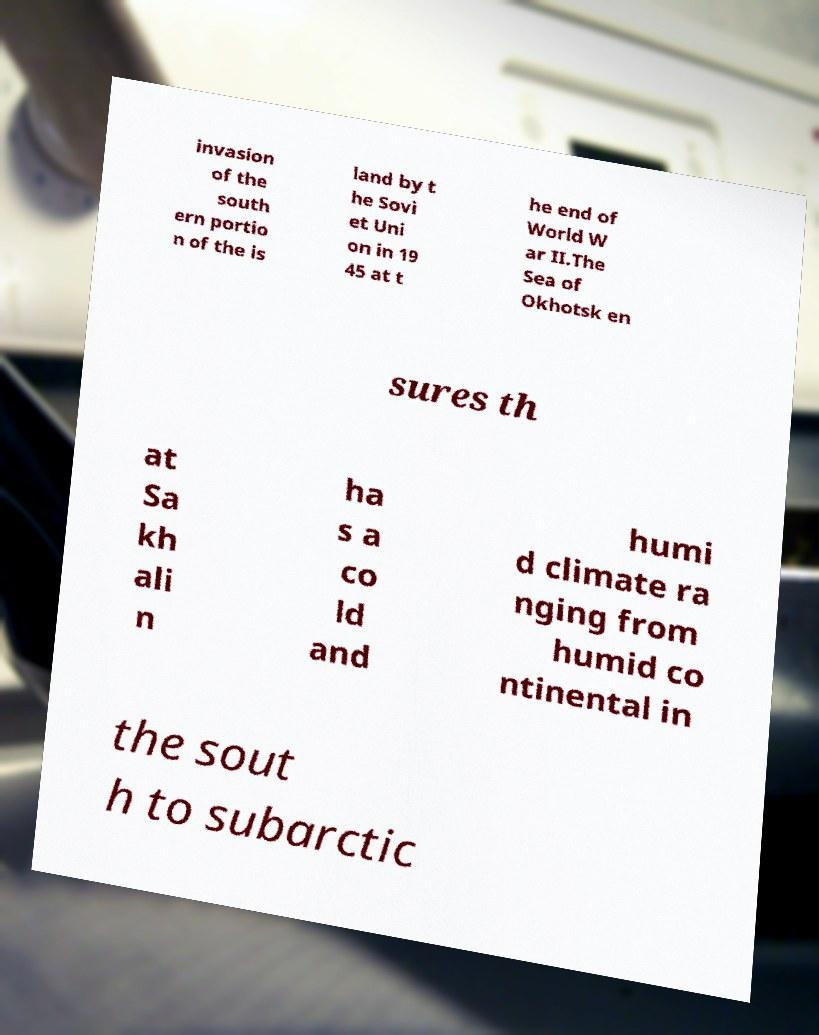I need the written content from this picture converted into text. Can you do that? invasion of the south ern portio n of the is land by t he Sovi et Uni on in 19 45 at t he end of World W ar II.The Sea of Okhotsk en sures th at Sa kh ali n ha s a co ld and humi d climate ra nging from humid co ntinental in the sout h to subarctic 